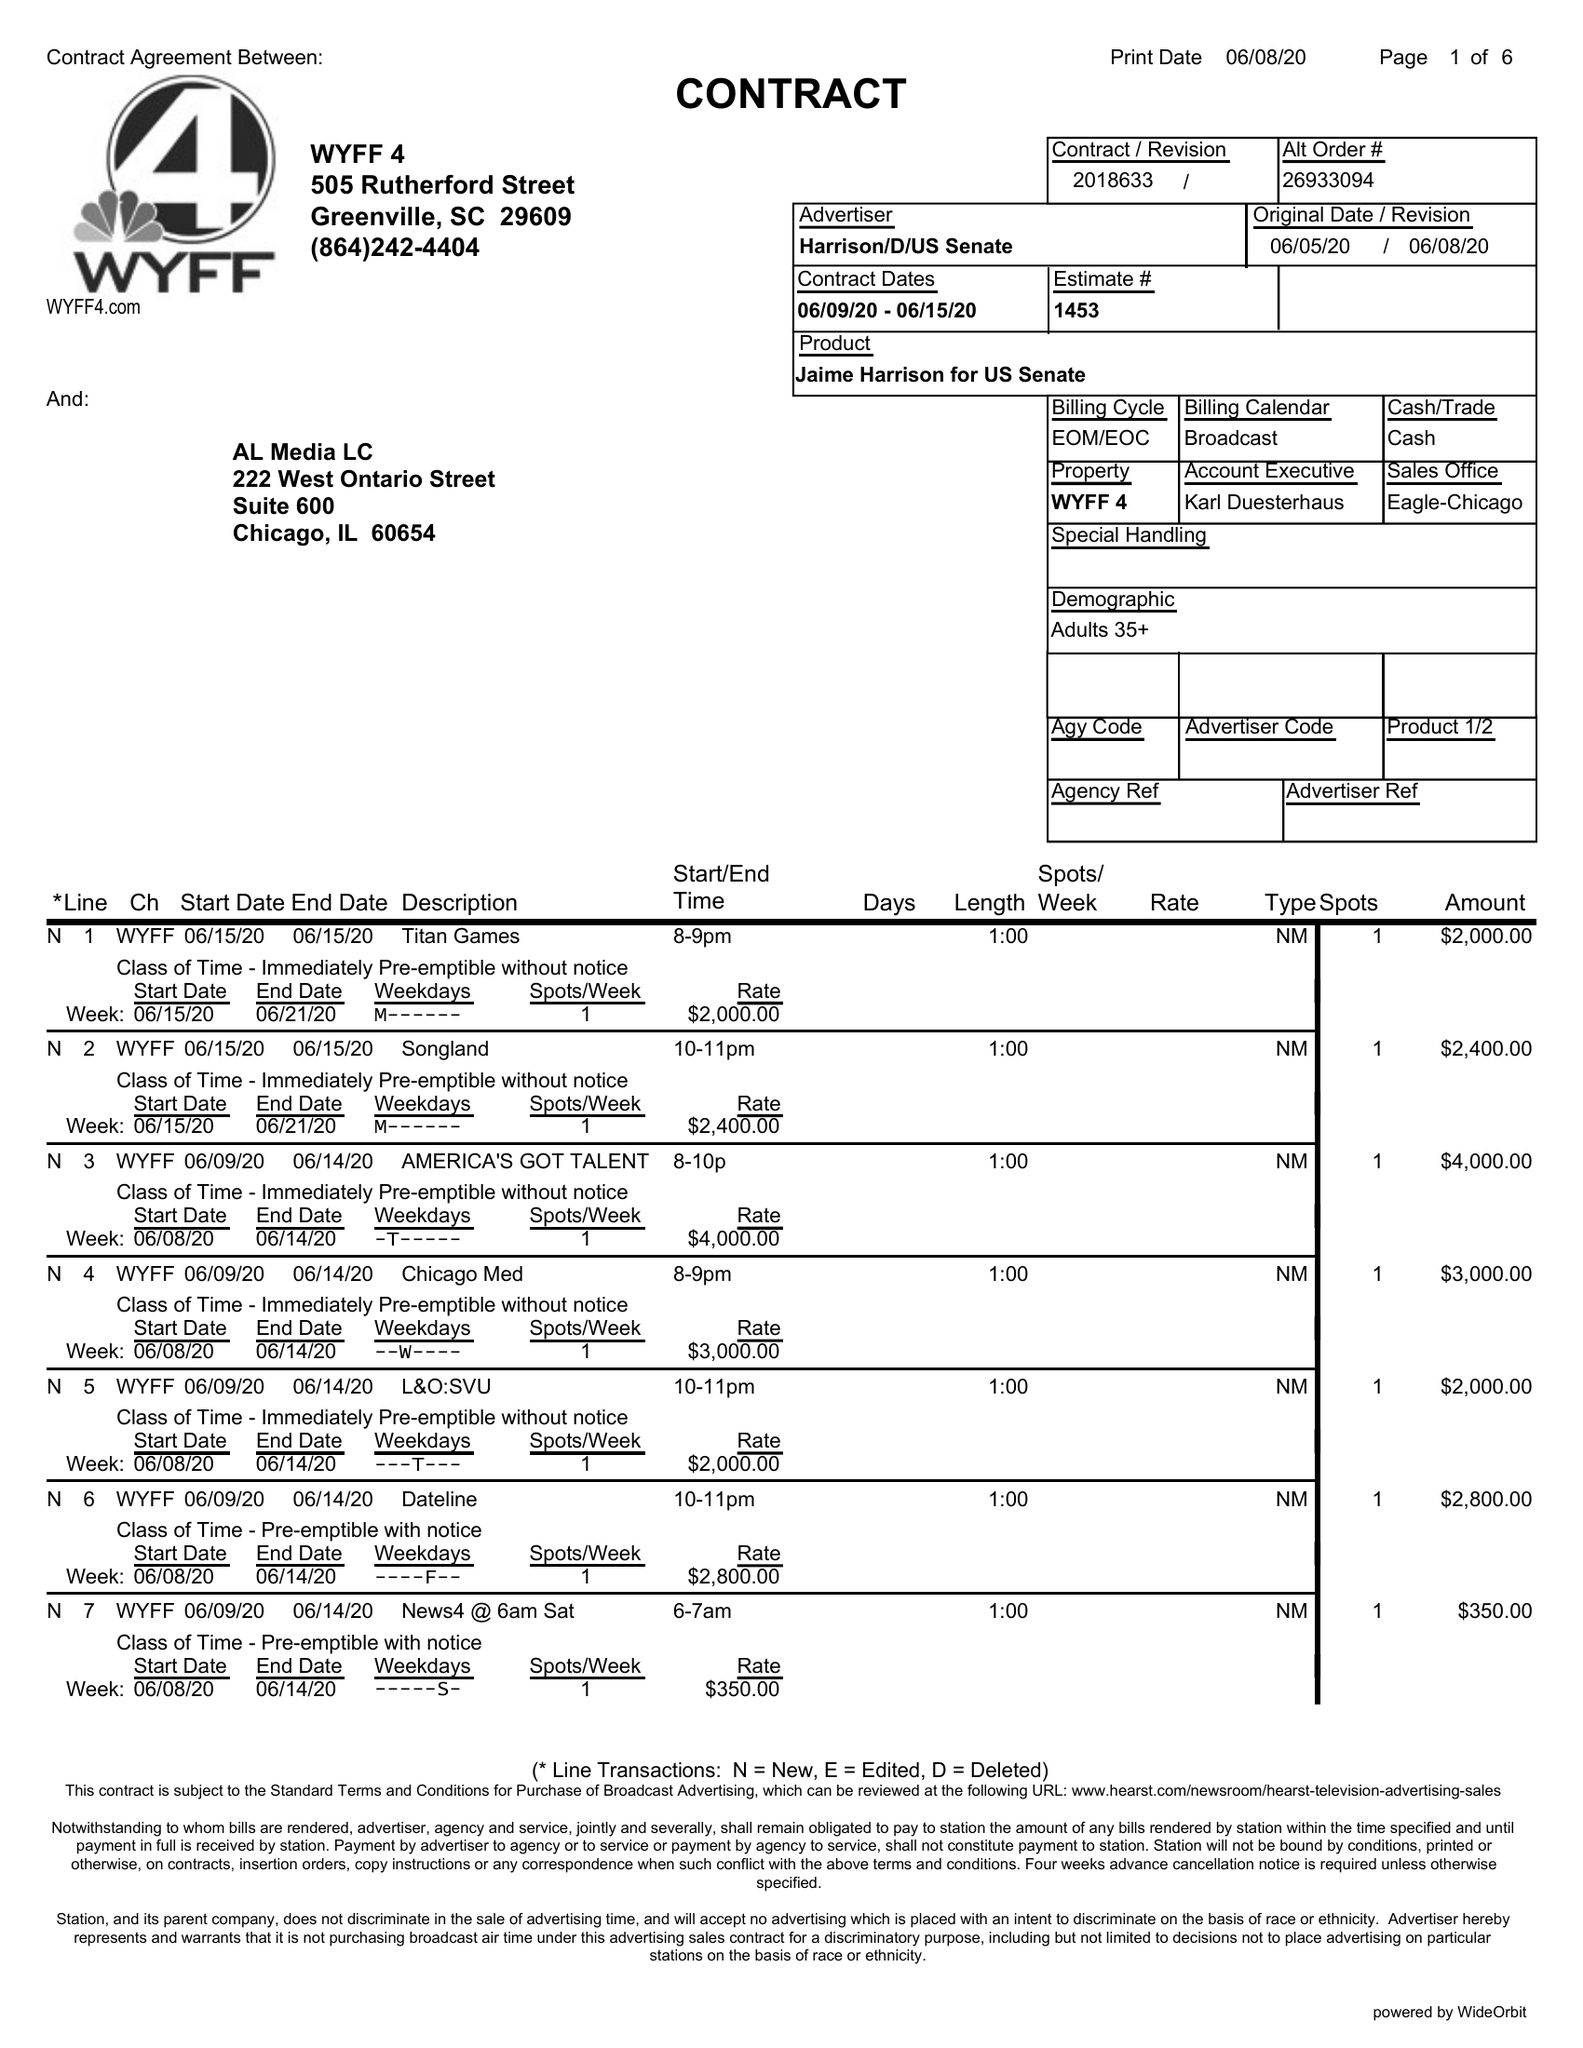What is the value for the gross_amount?
Answer the question using a single word or phrase. 56300.00 